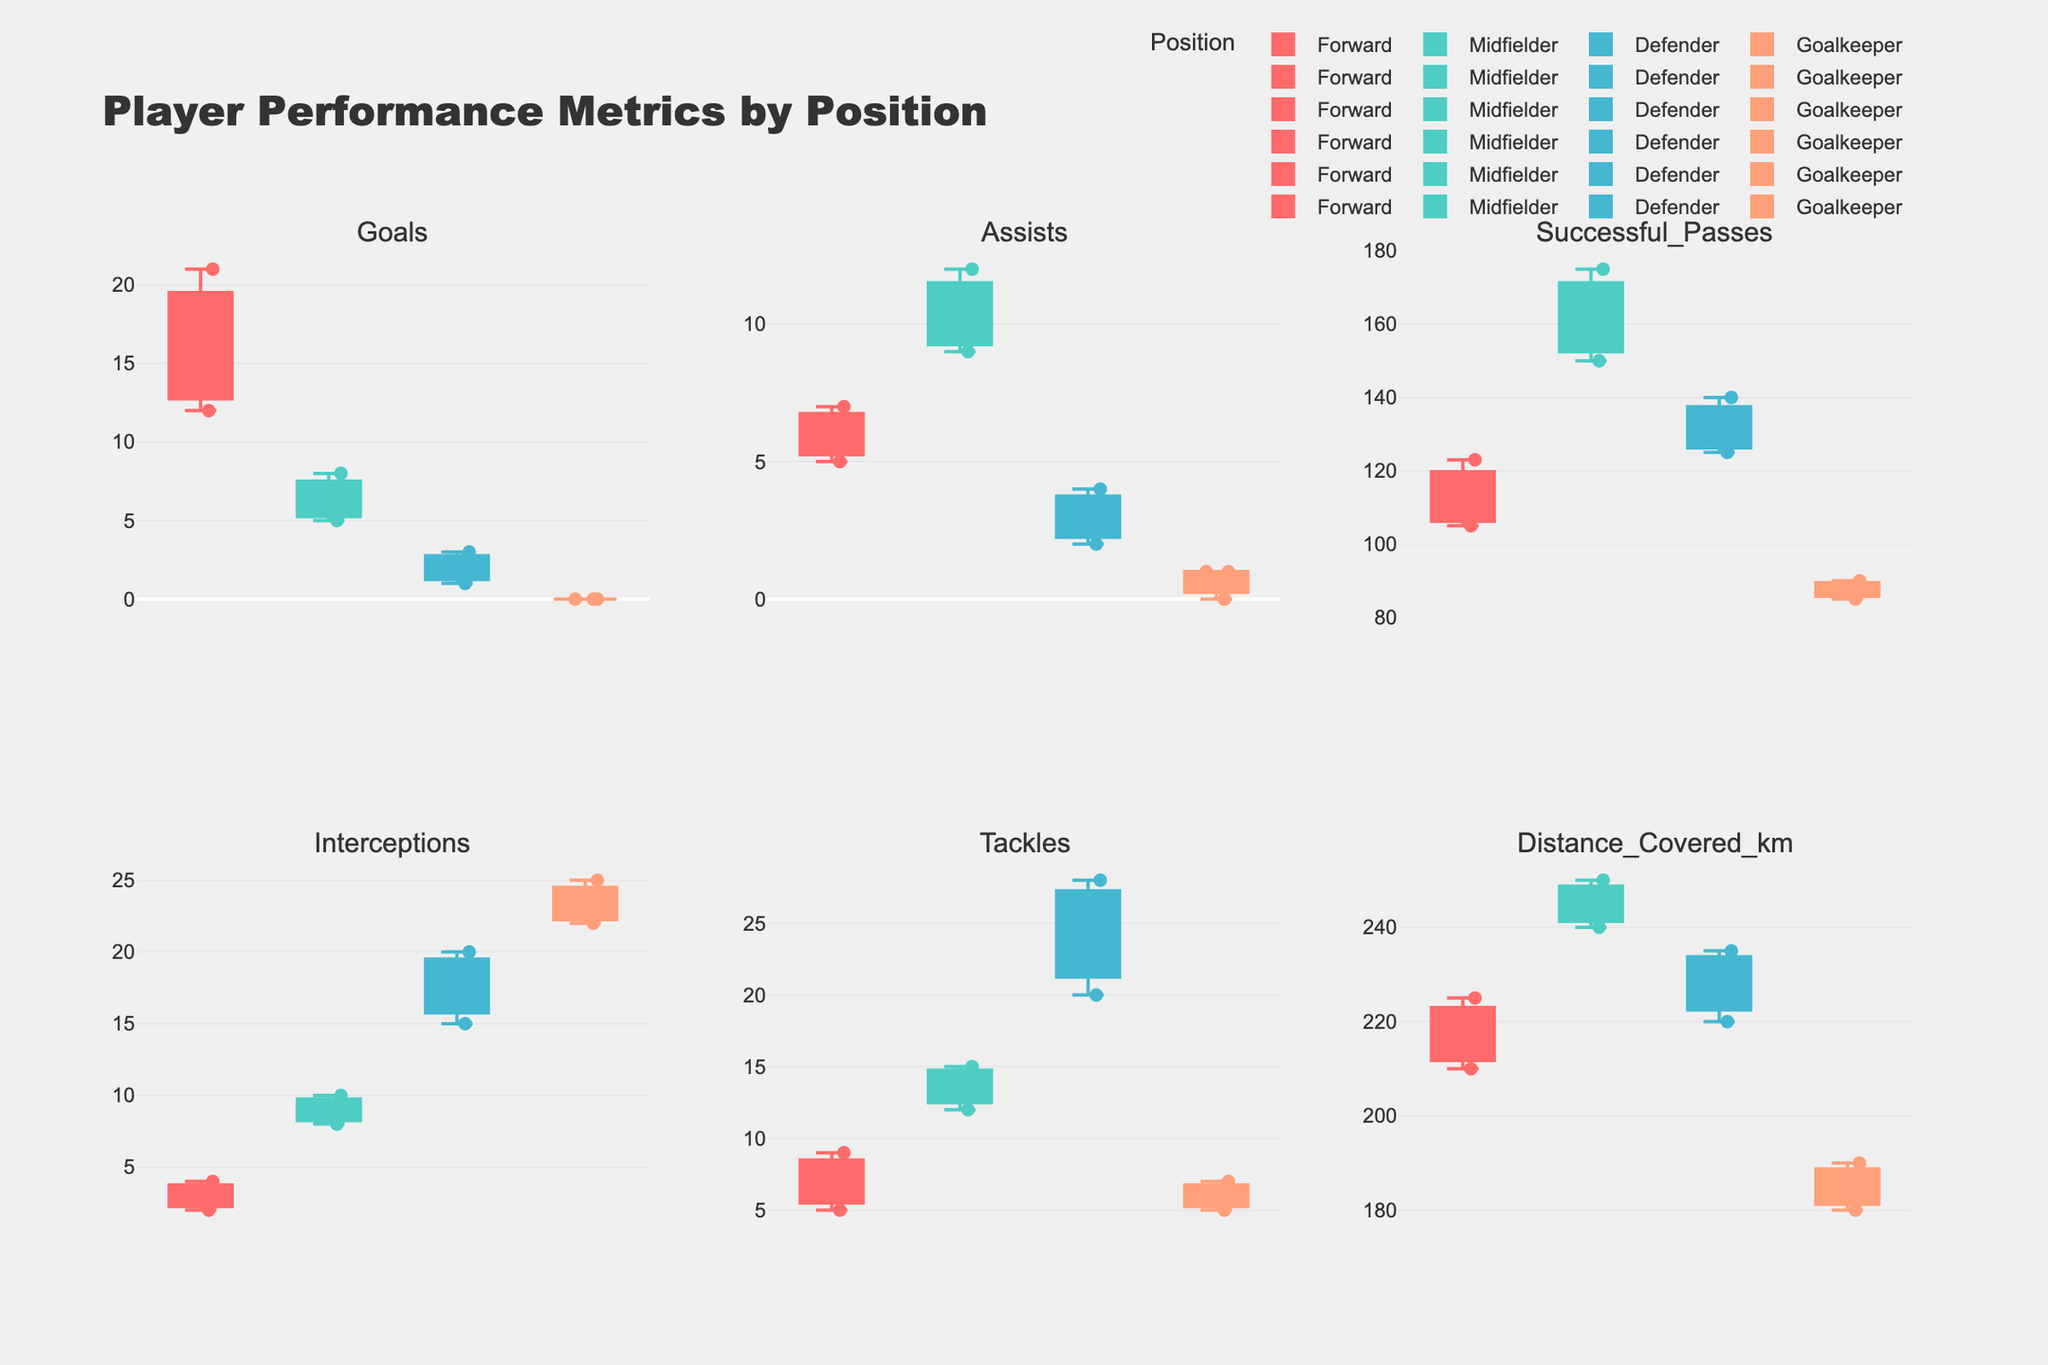what is the highest number of successful passes by a midfielder? To determine the highest number of successful passes by a midfielder, we need to focus only on the midfielder data points within the box plot for the 'Successful Passes' metric. By examining the plots, we see that the highest point within that box plot is the highest value.
Answer: 175 how does the median number of interceptions for defenders compare to that of goalkeepers? The median number of interceptions for defenders and goalkeepers can be identified by locating the middle line within each box plot for the 'Interceptions' metric. Compare the positions of the median lines for both defenders and goalkeepers.
Answer: Defenders median higher than goalkeepers which position covers the most distance on average? To find which position covers the most distance on average, we compare the spread and central tendency (like median) of each box plot for 'Distance Covered (km)'. The most distance covered on average would have a higher central tendency.
Answer: Midfielders which player has the lowest number of goals among forwards? To find the player with the lowest number of goals among forwards, locate the goals' box plot for the forward position, identify the lowest scatter point, then refer to the corresponding player.
Answer: John Stones is the variability in tackles greater for defenders or goalkeepers? Variability is indicated by the spread and length of the whiskers in a box plot. Compare the spread (whiskers and interquartile range) in the 'Tackles' metric between defenders and goalkeepers.
Answer: Defenders do midfielders have more assists than forwards on average? To compare, observe the box plots for the 'Assists' metric for both midfielders and forwards. Focus on the central tendency (like the mean or median) and overall spread of each box plot for both positions.
Answer: Yes which position shows the greatest range in the number of successful passes? The range is determined by the difference between the maximum and minimum values within a box plot. Check the range from the lowest to highest scatter points in the 'Successful Passes' metric for each position.
Answer: Midfielders how many positions have players that covered a distance of more than 240 km? For each position, check the scatter points in the 'Distance Covered (km)' box plot to identify those with values above 240 km and count the distinct positions.
Answer: 2 positions (Midfielders and Defenders) 